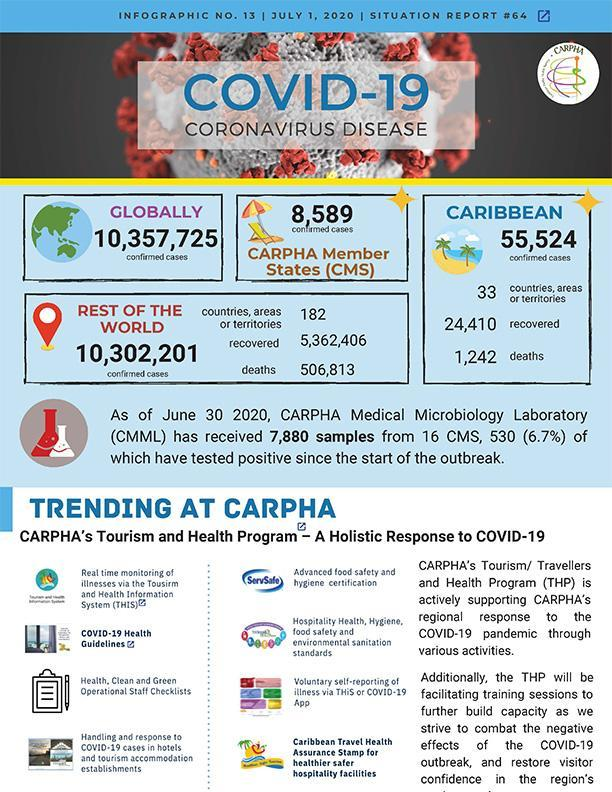What is the total number of confirmed COVID-19 cases reported globally as of July 1, 2020?
Answer the question with a short phrase. 10,357,725 What is the number of recovered COVID-19 cases reported in the Caribbean region as of July 1, 2020? 24,410 How many Covid-19 deaths were reported in the Caribbean region as of July 1, 2020? 1,242 What is the total number of confirmed COVID-19 cases reported in the CARPHA Member States as of July 1, 2020? 8,589 How many Covid-19 deaths were reported in the rest of the world as of July 1, 2020? 506,813 